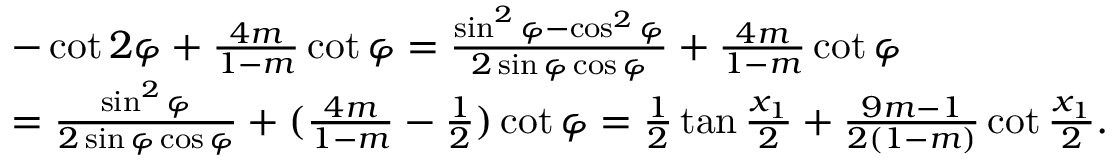Convert formula to latex. <formula><loc_0><loc_0><loc_500><loc_500>\begin{array} { r l } & { - \cot 2 \varphi + \frac { 4 m } { 1 - m } \cot \varphi = \frac { \sin ^ { 2 } \varphi - \cos ^ { 2 } \varphi } { 2 \sin \varphi \cos \varphi } + \frac { 4 m } { 1 - m } \cot \varphi } \\ & { = \frac { \sin ^ { 2 } \varphi } { 2 \sin \varphi \cos \varphi } + ( \frac { 4 m } { 1 - m } - \frac { 1 } { 2 } ) \cot \varphi = \frac { 1 } { 2 } \tan \frac { x _ { 1 } } { 2 } + \frac { 9 m - 1 } { 2 ( 1 - m ) } \cot \frac { x _ { 1 } } { 2 } . } \end{array}</formula> 